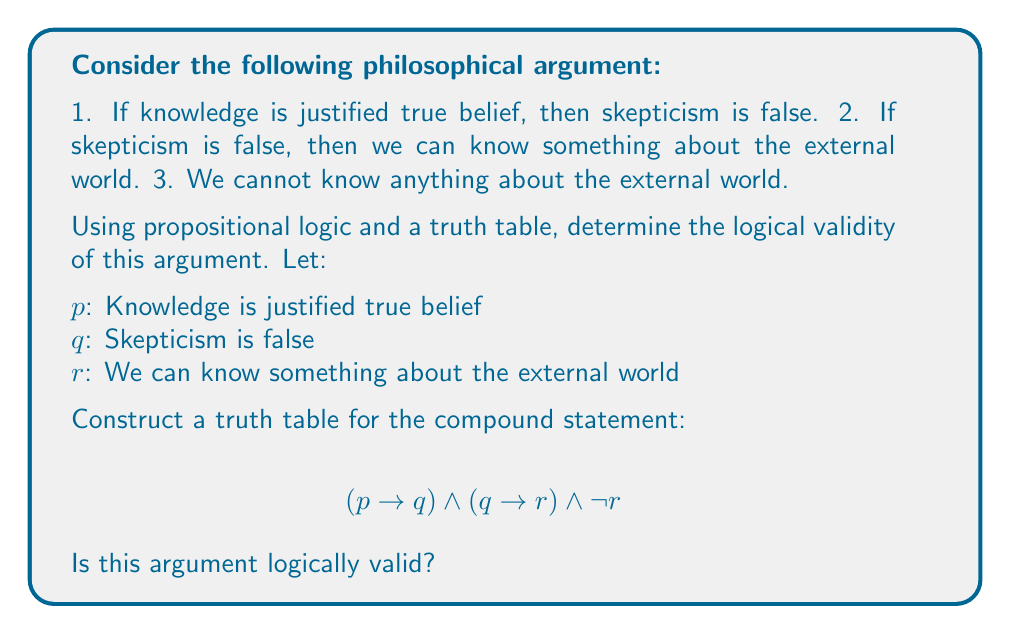Provide a solution to this math problem. Let's approach this step-by-step:

1) First, we need to translate the argument into symbolic form:
   $(p \rightarrow q) \land (q \rightarrow r) \land \lnot r$

2) Now, we'll construct a truth table for this compound statement. We need 8 rows for all possible combinations of truth values for $p$, $q$, and $r$.

3) Here's the truth table:

   $$\begin{array}{|c|c|c||c|c|c|c|}
   \hline
   p & q & r & p \rightarrow q & q \rightarrow r & \lnot r & (p \rightarrow q) \land (q \rightarrow r) \land \lnot r \\
   \hline
   T & T & T & T & T & F & F \\
   T & T & F & T & F & T & F \\
   T & F & T & F & T & F & F \\
   T & F & F & F & T & T & F \\
   F & T & T & T & T & F & F \\
   F & T & F & T & F & T & F \\
   F & F & T & T & T & F & F \\
   F & F & F & T & T & T & T \\
   \hline
   \end{array}$$

4) To determine if the argument is logically valid, we need to check if there's any row where all premises are true (i.e., $(p \rightarrow q) \land (q \rightarrow r) \land \lnot r$ is true) but the conclusion is false.

5) Looking at the last column of our truth table, we can see that the compound statement is true only in the last row, where $p$, $q$, and $r$ are all false.

6) In this case, all premises are true and the conclusion ($\lnot r$) is also true.

7) Since there's no row where all premises are true and the conclusion is false, this argument is logically valid.

This demonstrates that if we accept the premises of this argument, we must logically accept the conclusion, even though it leads to a skeptical view about our knowledge of the external world.
Answer: The argument is logically valid. 